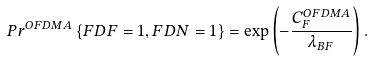Convert formula to latex. <formula><loc_0><loc_0><loc_500><loc_500>P r ^ { O F D M A } \left \{ F D F = 1 , F D N = 1 \right \} = \exp \left ( - \frac { C _ { F } ^ { O F D M A } } { \lambda _ { B F } } \right ) .</formula> 